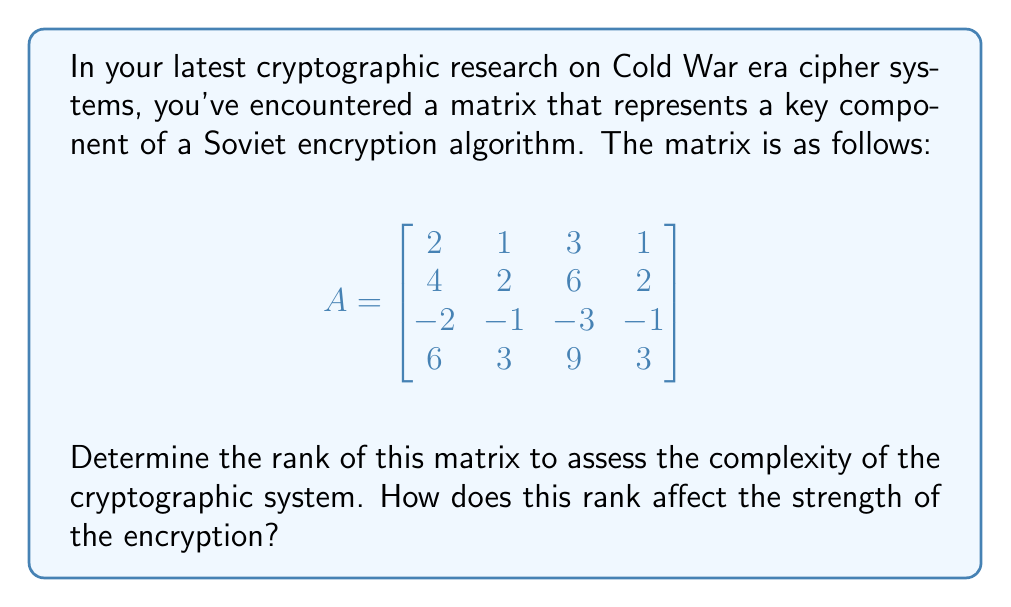Could you help me with this problem? To determine the rank of the matrix, we need to perform row reduction to obtain the row echelon form. Let's go through this process step-by-step:

1) First, let's divide the second row by 2 to make the leading coefficient 1:
   $$\begin{bmatrix}
   2 & 1 & 3 & 1 \\
   2 & 1 & 3 & 1 \\
   -2 & -1 & -3 & -1 \\
   6 & 3 & 9 & 3
   \end{bmatrix}$$

2) Now, subtract row 2 from row 1:
   $$\begin{bmatrix}
   0 & 0 & 0 & 0 \\
   2 & 1 & 3 & 1 \\
   -2 & -1 & -3 & -1 \\
   6 & 3 & 9 & 3
   \end{bmatrix}$$

3) Add row 2 to row 3:
   $$\begin{bmatrix}
   0 & 0 & 0 & 0 \\
   2 & 1 & 3 & 1 \\
   0 & 0 & 0 & 0 \\
   6 & 3 & 9 & 3
   \end{bmatrix}$$

4) Subtract 3 times row 2 from row 4:
   $$\begin{bmatrix}
   0 & 0 & 0 & 0 \\
   2 & 1 & 3 & 1 \\
   0 & 0 & 0 & 0 \\
   0 & 0 & 0 & 0
   \end{bmatrix}$$

The resulting matrix is in row echelon form. The rank of the matrix is equal to the number of non-zero rows, which in this case is 1.

This low rank indicates that the cryptographic system has a relatively low complexity. In cryptography, a higher rank generally corresponds to a more complex and potentially more secure system. A rank of 1 suggests that all rows of the original matrix are linearly dependent, which could potentially make the system vulnerable to certain types of cryptanalysis.

For a 4x4 matrix, a rank of 4 (full rank) would typically indicate a stronger encryption system, as it would suggest that all rows are linearly independent, potentially providing more diversity in the encryption process.
Answer: Rank: 1. This low rank indicates a relatively weak encryption system due to high linear dependence among the matrix rows. 